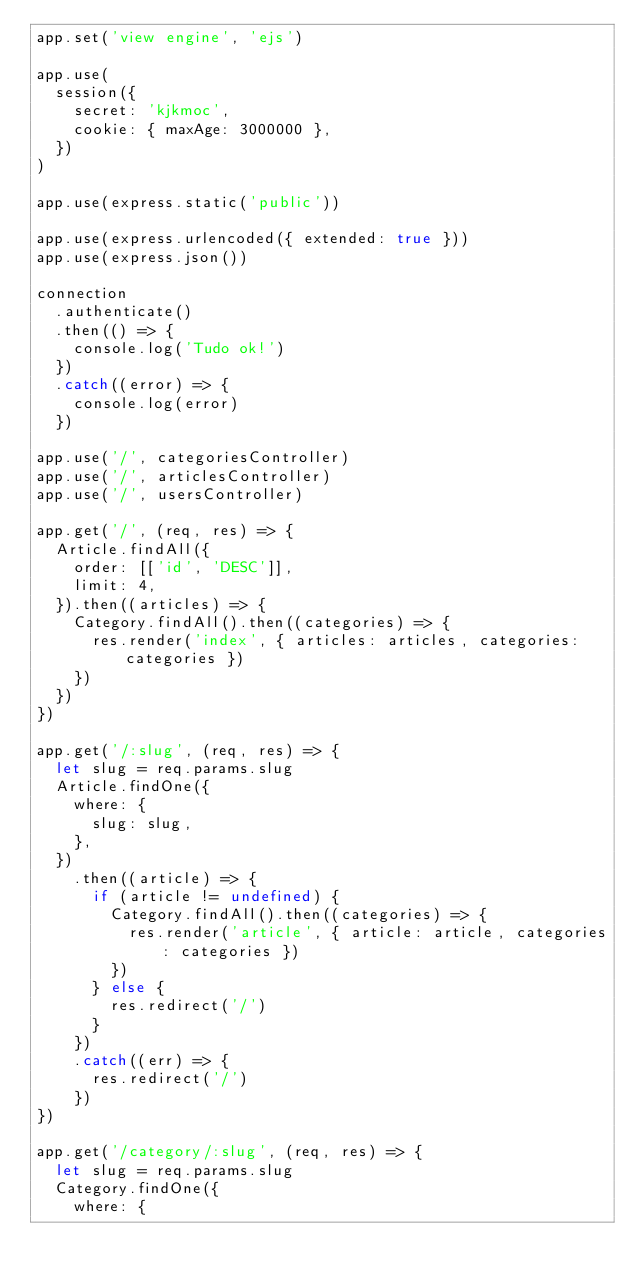Convert code to text. <code><loc_0><loc_0><loc_500><loc_500><_JavaScript_>app.set('view engine', 'ejs')

app.use(
  session({
    secret: 'kjkmoc',
    cookie: { maxAge: 3000000 },
  })
)

app.use(express.static('public'))

app.use(express.urlencoded({ extended: true }))
app.use(express.json())

connection
  .authenticate()
  .then(() => {
    console.log('Tudo ok!')
  })
  .catch((error) => {
    console.log(error)
  })

app.use('/', categoriesController)
app.use('/', articlesController)
app.use('/', usersController)

app.get('/', (req, res) => {
  Article.findAll({
    order: [['id', 'DESC']],
    limit: 4,
  }).then((articles) => {
    Category.findAll().then((categories) => {
      res.render('index', { articles: articles, categories: categories })
    })
  })
})

app.get('/:slug', (req, res) => {
  let slug = req.params.slug
  Article.findOne({
    where: {
      slug: slug,
    },
  })
    .then((article) => {
      if (article != undefined) {
        Category.findAll().then((categories) => {
          res.render('article', { article: article, categories: categories })
        })
      } else {
        res.redirect('/')
      }
    })
    .catch((err) => {
      res.redirect('/')
    })
})

app.get('/category/:slug', (req, res) => {
  let slug = req.params.slug
  Category.findOne({
    where: {</code> 